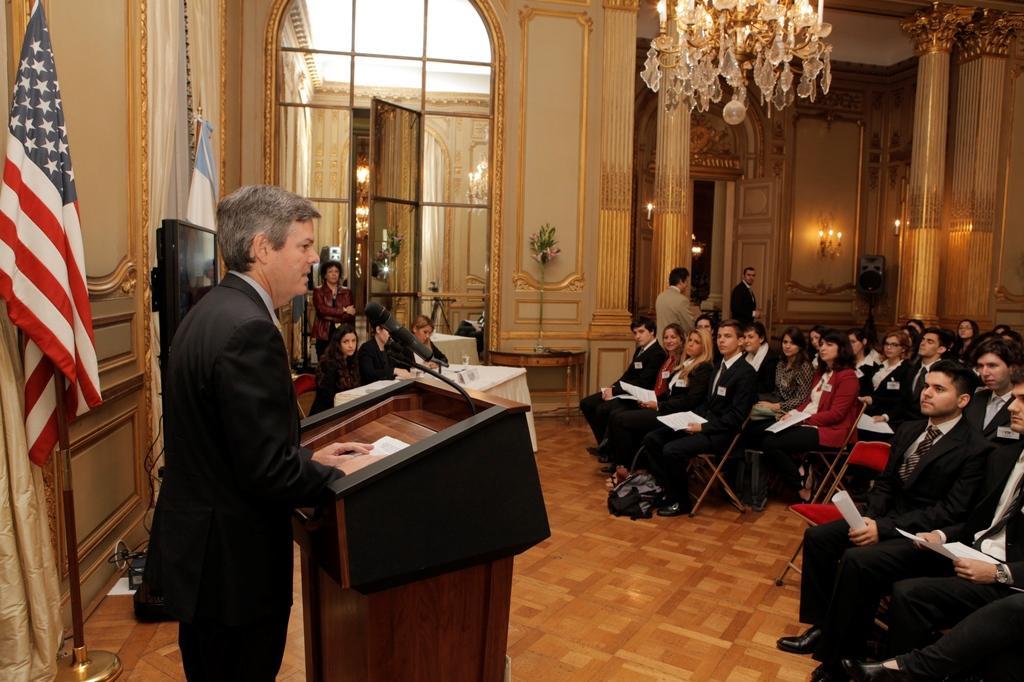Could you give a brief overview of what you see in this image? On the left side, there is a person in a suit, standing and keeping both hands on the stand, on which there is a mic attached to a stand, there is a flag and there is a curtain. On the right side, there are persons sitting on the chairs which are arranged on the floor. In the background, there are persons sitting, there are persons standing, there are lights attached to the wall and there is a light attached to the roof. 